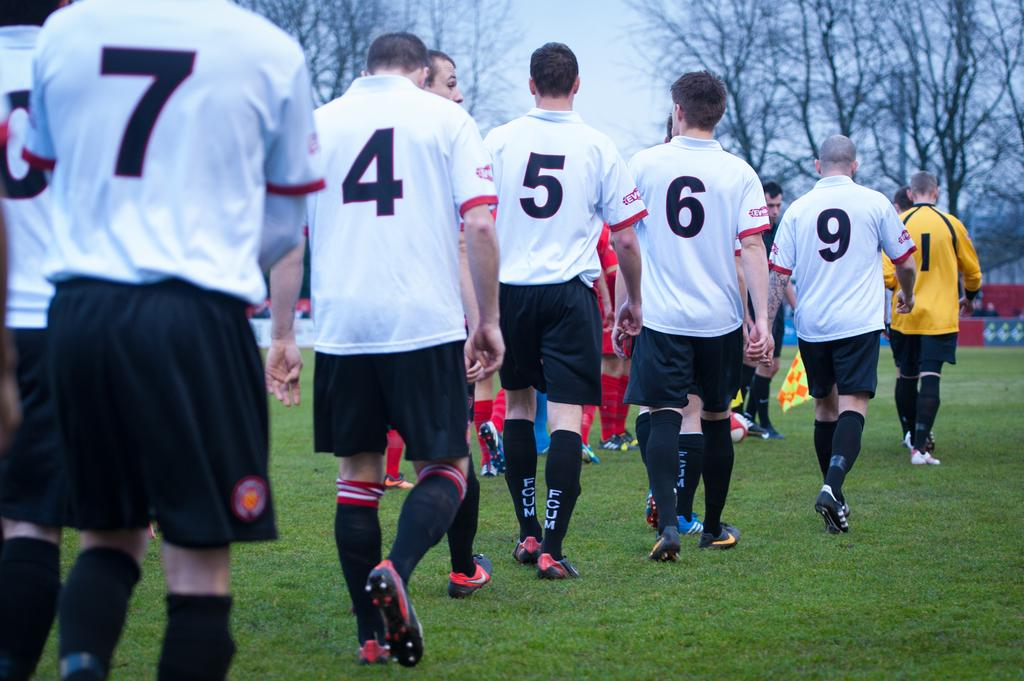What are the people in the image doing? There are many people walking in the image. What type of surface are the people walking on? The ground has grass. What can be seen on the people's t-shirts? The people have numbers on their t-shirts. What can be seen in the background of the image? There are trees and the sky visible in the background of the image. What type of steel is used to construct the ship in the image? There is no ship present in the image, so it is not possible to determine the type of steel used in its construction. What is inside the jar that is visible in the image? There is no jar present in the image. 